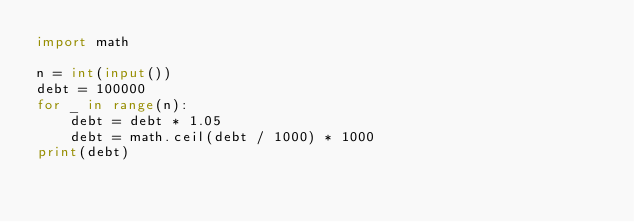<code> <loc_0><loc_0><loc_500><loc_500><_Python_>import math

n = int(input())
debt = 100000
for _ in range(n):
    debt = debt * 1.05
    debt = math.ceil(debt / 1000) * 1000
print(debt)
</code> 